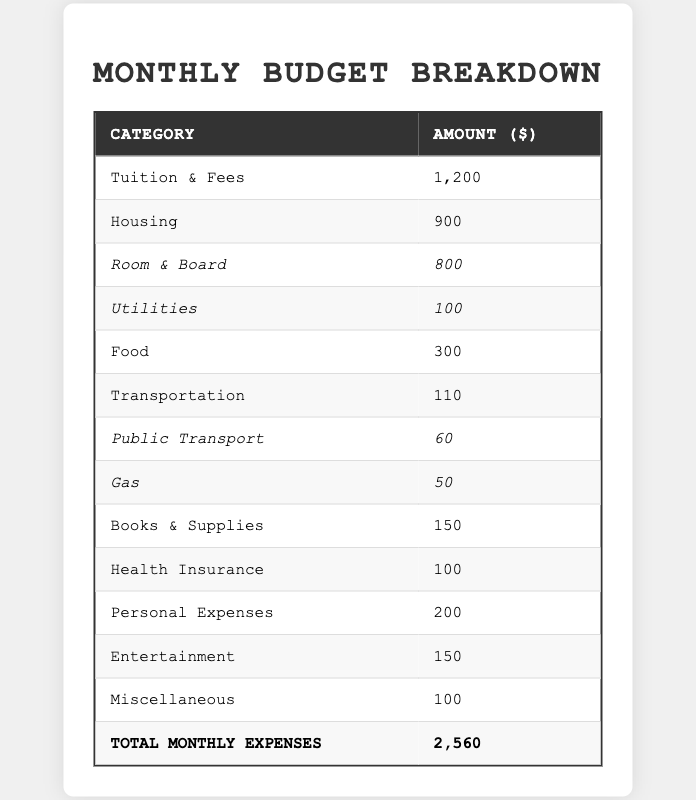What is the total amount allocated for Food in the budget? The table lists the Food budget under the category "Food," which shows an amount of $300.
Answer: 300 How much is spent on Utilities each month? Utilities are categorized under Housing, and the table shows that the amount spent on Utilities is $100.
Answer: 100 What is the combined cost of Gas and Public Transport for transportation? The amount for Public Transport is $60 and for Gas is $50. Adding these amounts gives $60 + $50 = $110.
Answer: 110 Is the amount allocated for Health Insurance greater than that for Personal Expenses? Health Insurance is set at $100 and Personal Expenses at $200. Since $100 is less than $200, the answer is no.
Answer: No What percentage of the total monthly expenses is spent on Tuition & Fees? Tuition & Fees amount to $1200. Total monthly expenses are $2560. The percentage can be calculated as ($1200 / $2560) * 100 = 46.88%.
Answer: 46.88% If the total monthly expenses were to increase by $200, what would the new total be? The current total monthly expenses are $2560. Adding $200 gives $2560 + $200 = $2760.
Answer: 2760 What is the total monthly cost for Housing, including Room and Board and Utilities? Room and Board is $800 and Utilities is $100. Adding these gives $800 + $100 = $900, which is the total for Housing.
Answer: 900 Does the budget allocate more for Food than for Entertainment? Food is allocated $300, while Entertainment is allocated $150. Since $300 is greater than $150, the answer is yes.
Answer: Yes What is the sum of all the costs in the Transportation category? Public Transport is $60 and Gas is $50. The sum is $60 + $50 = $110, which is the total for Transportation.
Answer: 110 If you were to spend $50 less on Personal Expenses, what would the new total monthly expenses be? The current total monthly expenses are $2560. Spending $50 less means the new total would be $2560 - $50 = $2510.
Answer: 2510 